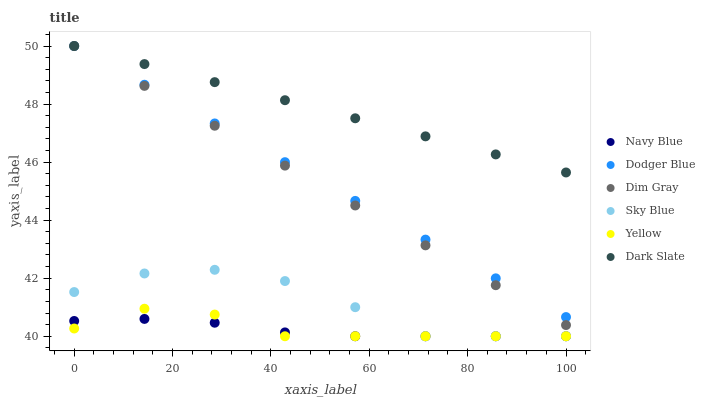Does Navy Blue have the minimum area under the curve?
Answer yes or no. Yes. Does Dark Slate have the maximum area under the curve?
Answer yes or no. Yes. Does Yellow have the minimum area under the curve?
Answer yes or no. No. Does Yellow have the maximum area under the curve?
Answer yes or no. No. Is Dark Slate the smoothest?
Answer yes or no. Yes. Is Sky Blue the roughest?
Answer yes or no. Yes. Is Navy Blue the smoothest?
Answer yes or no. No. Is Navy Blue the roughest?
Answer yes or no. No. Does Navy Blue have the lowest value?
Answer yes or no. Yes. Does Dark Slate have the lowest value?
Answer yes or no. No. Does Dodger Blue have the highest value?
Answer yes or no. Yes. Does Yellow have the highest value?
Answer yes or no. No. Is Yellow less than Dark Slate?
Answer yes or no. Yes. Is Dim Gray greater than Navy Blue?
Answer yes or no. Yes. Does Yellow intersect Navy Blue?
Answer yes or no. Yes. Is Yellow less than Navy Blue?
Answer yes or no. No. Is Yellow greater than Navy Blue?
Answer yes or no. No. Does Yellow intersect Dark Slate?
Answer yes or no. No. 